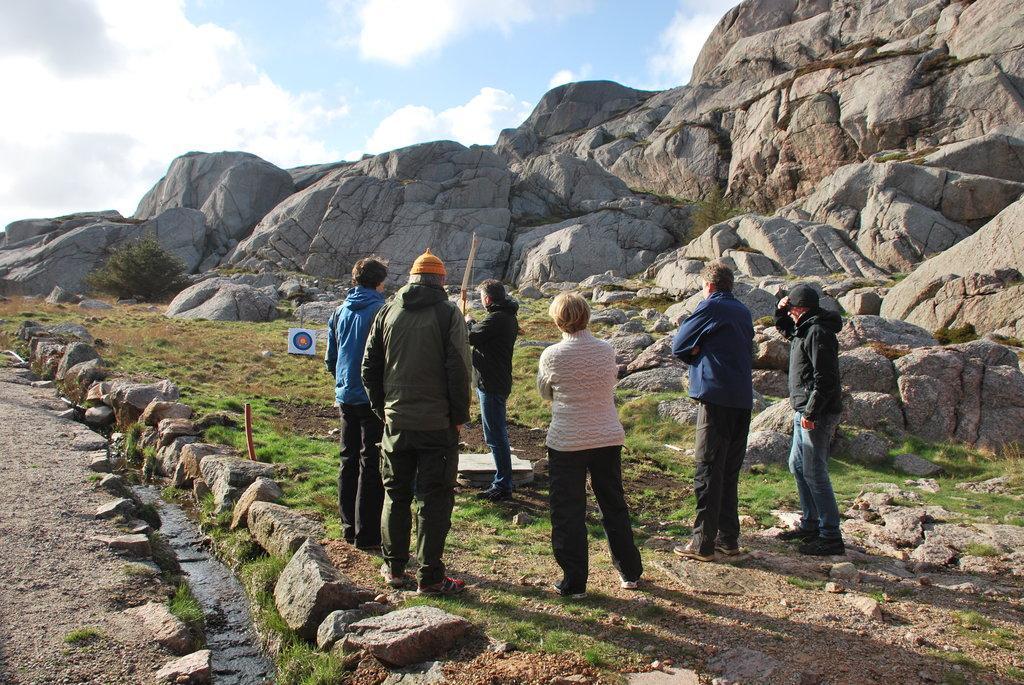Describe this image in one or two sentences. This picture is clicked outside. In the center we can see the group of persons standing on the ground and there is a person holding a bow and standing on the ground and we can see the grass and a target of archery is placed on the ground and we can see the rocks and the sky. 